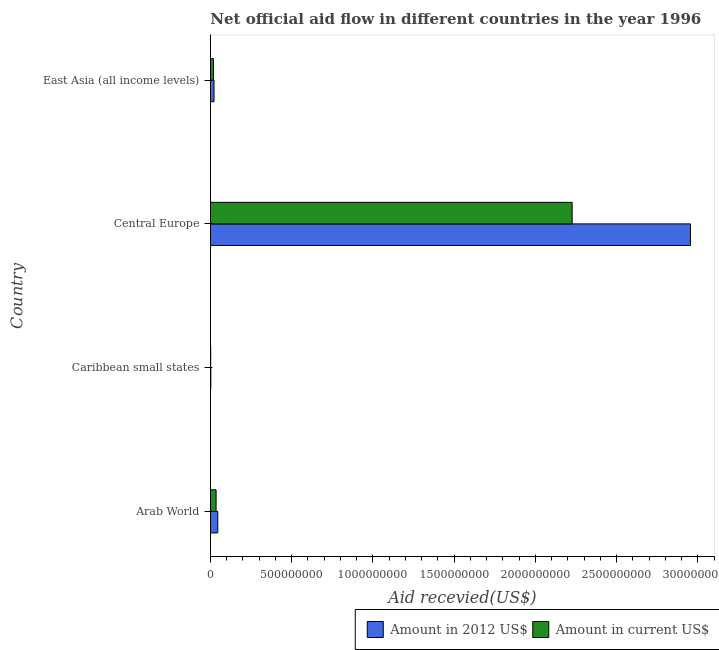How many different coloured bars are there?
Provide a succinct answer. 2. How many bars are there on the 1st tick from the top?
Keep it short and to the point. 2. What is the label of the 2nd group of bars from the top?
Your answer should be compact. Central Europe. In how many cases, is the number of bars for a given country not equal to the number of legend labels?
Your answer should be compact. 0. What is the amount of aid received(expressed in 2012 us$) in Central Europe?
Your answer should be very brief. 2.96e+09. Across all countries, what is the maximum amount of aid received(expressed in 2012 us$)?
Give a very brief answer. 2.96e+09. Across all countries, what is the minimum amount of aid received(expressed in 2012 us$)?
Your answer should be compact. 2.04e+06. In which country was the amount of aid received(expressed in us$) maximum?
Provide a succinct answer. Central Europe. In which country was the amount of aid received(expressed in us$) minimum?
Offer a very short reply. Caribbean small states. What is the total amount of aid received(expressed in 2012 us$) in the graph?
Your answer should be very brief. 3.02e+09. What is the difference between the amount of aid received(expressed in 2012 us$) in Arab World and that in Caribbean small states?
Offer a terse response. 4.31e+07. What is the difference between the amount of aid received(expressed in us$) in Central Europe and the amount of aid received(expressed in 2012 us$) in Caribbean small states?
Offer a terse response. 2.22e+09. What is the average amount of aid received(expressed in us$) per country?
Keep it short and to the point. 5.70e+08. What is the difference between the amount of aid received(expressed in us$) and amount of aid received(expressed in 2012 us$) in Caribbean small states?
Your answer should be compact. -5.90e+05. In how many countries, is the amount of aid received(expressed in us$) greater than 2300000000 US$?
Ensure brevity in your answer.  0. What is the ratio of the amount of aid received(expressed in us$) in Arab World to that in Caribbean small states?
Provide a short and direct response. 23.86. Is the difference between the amount of aid received(expressed in us$) in Caribbean small states and East Asia (all income levels) greater than the difference between the amount of aid received(expressed in 2012 us$) in Caribbean small states and East Asia (all income levels)?
Your answer should be very brief. Yes. What is the difference between the highest and the second highest amount of aid received(expressed in 2012 us$)?
Ensure brevity in your answer.  2.91e+09. What is the difference between the highest and the lowest amount of aid received(expressed in us$)?
Offer a terse response. 2.23e+09. In how many countries, is the amount of aid received(expressed in 2012 us$) greater than the average amount of aid received(expressed in 2012 us$) taken over all countries?
Provide a succinct answer. 1. Is the sum of the amount of aid received(expressed in 2012 us$) in Caribbean small states and Central Europe greater than the maximum amount of aid received(expressed in us$) across all countries?
Give a very brief answer. Yes. What does the 1st bar from the top in Arab World represents?
Provide a short and direct response. Amount in current US$. What does the 2nd bar from the bottom in Caribbean small states represents?
Offer a very short reply. Amount in current US$. How many bars are there?
Your response must be concise. 8. How many countries are there in the graph?
Your answer should be very brief. 4. What is the difference between two consecutive major ticks on the X-axis?
Your response must be concise. 5.00e+08. Does the graph contain grids?
Offer a terse response. No. How many legend labels are there?
Offer a terse response. 2. What is the title of the graph?
Give a very brief answer. Net official aid flow in different countries in the year 1996. Does "Money lenders" appear as one of the legend labels in the graph?
Provide a short and direct response. No. What is the label or title of the X-axis?
Provide a short and direct response. Aid recevied(US$). What is the Aid recevied(US$) of Amount in 2012 US$ in Arab World?
Offer a terse response. 4.51e+07. What is the Aid recevied(US$) of Amount in current US$ in Arab World?
Your answer should be compact. 3.46e+07. What is the Aid recevied(US$) in Amount in 2012 US$ in Caribbean small states?
Give a very brief answer. 2.04e+06. What is the Aid recevied(US$) in Amount in current US$ in Caribbean small states?
Your response must be concise. 1.45e+06. What is the Aid recevied(US$) in Amount in 2012 US$ in Central Europe?
Ensure brevity in your answer.  2.96e+09. What is the Aid recevied(US$) in Amount in current US$ in Central Europe?
Make the answer very short. 2.23e+09. What is the Aid recevied(US$) of Amount in 2012 US$ in East Asia (all income levels)?
Your response must be concise. 2.17e+07. What is the Aid recevied(US$) of Amount in current US$ in East Asia (all income levels)?
Make the answer very short. 1.80e+07. Across all countries, what is the maximum Aid recevied(US$) in Amount in 2012 US$?
Provide a short and direct response. 2.96e+09. Across all countries, what is the maximum Aid recevied(US$) in Amount in current US$?
Your response must be concise. 2.23e+09. Across all countries, what is the minimum Aid recevied(US$) in Amount in 2012 US$?
Offer a very short reply. 2.04e+06. Across all countries, what is the minimum Aid recevied(US$) in Amount in current US$?
Offer a terse response. 1.45e+06. What is the total Aid recevied(US$) of Amount in 2012 US$ in the graph?
Your response must be concise. 3.02e+09. What is the total Aid recevied(US$) of Amount in current US$ in the graph?
Offer a very short reply. 2.28e+09. What is the difference between the Aid recevied(US$) of Amount in 2012 US$ in Arab World and that in Caribbean small states?
Offer a terse response. 4.31e+07. What is the difference between the Aid recevied(US$) of Amount in current US$ in Arab World and that in Caribbean small states?
Give a very brief answer. 3.31e+07. What is the difference between the Aid recevied(US$) in Amount in 2012 US$ in Arab World and that in Central Europe?
Give a very brief answer. -2.91e+09. What is the difference between the Aid recevied(US$) of Amount in current US$ in Arab World and that in Central Europe?
Make the answer very short. -2.19e+09. What is the difference between the Aid recevied(US$) in Amount in 2012 US$ in Arab World and that in East Asia (all income levels)?
Your answer should be very brief. 2.34e+07. What is the difference between the Aid recevied(US$) of Amount in current US$ in Arab World and that in East Asia (all income levels)?
Give a very brief answer. 1.65e+07. What is the difference between the Aid recevied(US$) in Amount in 2012 US$ in Caribbean small states and that in Central Europe?
Give a very brief answer. -2.95e+09. What is the difference between the Aid recevied(US$) in Amount in current US$ in Caribbean small states and that in Central Europe?
Provide a short and direct response. -2.23e+09. What is the difference between the Aid recevied(US$) of Amount in 2012 US$ in Caribbean small states and that in East Asia (all income levels)?
Offer a very short reply. -1.96e+07. What is the difference between the Aid recevied(US$) of Amount in current US$ in Caribbean small states and that in East Asia (all income levels)?
Your response must be concise. -1.66e+07. What is the difference between the Aid recevied(US$) in Amount in 2012 US$ in Central Europe and that in East Asia (all income levels)?
Offer a very short reply. 2.93e+09. What is the difference between the Aid recevied(US$) in Amount in current US$ in Central Europe and that in East Asia (all income levels)?
Provide a short and direct response. 2.21e+09. What is the difference between the Aid recevied(US$) of Amount in 2012 US$ in Arab World and the Aid recevied(US$) of Amount in current US$ in Caribbean small states?
Offer a terse response. 4.37e+07. What is the difference between the Aid recevied(US$) of Amount in 2012 US$ in Arab World and the Aid recevied(US$) of Amount in current US$ in Central Europe?
Ensure brevity in your answer.  -2.18e+09. What is the difference between the Aid recevied(US$) of Amount in 2012 US$ in Arab World and the Aid recevied(US$) of Amount in current US$ in East Asia (all income levels)?
Your answer should be very brief. 2.71e+07. What is the difference between the Aid recevied(US$) of Amount in 2012 US$ in Caribbean small states and the Aid recevied(US$) of Amount in current US$ in Central Europe?
Provide a short and direct response. -2.22e+09. What is the difference between the Aid recevied(US$) in Amount in 2012 US$ in Caribbean small states and the Aid recevied(US$) in Amount in current US$ in East Asia (all income levels)?
Your answer should be compact. -1.60e+07. What is the difference between the Aid recevied(US$) in Amount in 2012 US$ in Central Europe and the Aid recevied(US$) in Amount in current US$ in East Asia (all income levels)?
Provide a short and direct response. 2.94e+09. What is the average Aid recevied(US$) in Amount in 2012 US$ per country?
Keep it short and to the point. 7.56e+08. What is the average Aid recevied(US$) of Amount in current US$ per country?
Your answer should be compact. 5.70e+08. What is the difference between the Aid recevied(US$) in Amount in 2012 US$ and Aid recevied(US$) in Amount in current US$ in Arab World?
Provide a succinct answer. 1.05e+07. What is the difference between the Aid recevied(US$) of Amount in 2012 US$ and Aid recevied(US$) of Amount in current US$ in Caribbean small states?
Your answer should be very brief. 5.90e+05. What is the difference between the Aid recevied(US$) in Amount in 2012 US$ and Aid recevied(US$) in Amount in current US$ in Central Europe?
Make the answer very short. 7.29e+08. What is the difference between the Aid recevied(US$) in Amount in 2012 US$ and Aid recevied(US$) in Amount in current US$ in East Asia (all income levels)?
Your response must be concise. 3.64e+06. What is the ratio of the Aid recevied(US$) of Amount in 2012 US$ in Arab World to that in Caribbean small states?
Keep it short and to the point. 22.12. What is the ratio of the Aid recevied(US$) in Amount in current US$ in Arab World to that in Caribbean small states?
Give a very brief answer. 23.86. What is the ratio of the Aid recevied(US$) of Amount in 2012 US$ in Arab World to that in Central Europe?
Make the answer very short. 0.02. What is the ratio of the Aid recevied(US$) in Amount in current US$ in Arab World to that in Central Europe?
Provide a short and direct response. 0.02. What is the ratio of the Aid recevied(US$) in Amount in 2012 US$ in Arab World to that in East Asia (all income levels)?
Offer a terse response. 2.08. What is the ratio of the Aid recevied(US$) of Amount in current US$ in Arab World to that in East Asia (all income levels)?
Offer a very short reply. 1.92. What is the ratio of the Aid recevied(US$) in Amount in 2012 US$ in Caribbean small states to that in Central Europe?
Provide a succinct answer. 0. What is the ratio of the Aid recevied(US$) in Amount in current US$ in Caribbean small states to that in Central Europe?
Make the answer very short. 0. What is the ratio of the Aid recevied(US$) in Amount in 2012 US$ in Caribbean small states to that in East Asia (all income levels)?
Make the answer very short. 0.09. What is the ratio of the Aid recevied(US$) in Amount in current US$ in Caribbean small states to that in East Asia (all income levels)?
Your response must be concise. 0.08. What is the ratio of the Aid recevied(US$) of Amount in 2012 US$ in Central Europe to that in East Asia (all income levels)?
Offer a terse response. 136.24. What is the ratio of the Aid recevied(US$) of Amount in current US$ in Central Europe to that in East Asia (all income levels)?
Make the answer very short. 123.35. What is the difference between the highest and the second highest Aid recevied(US$) of Amount in 2012 US$?
Provide a succinct answer. 2.91e+09. What is the difference between the highest and the second highest Aid recevied(US$) of Amount in current US$?
Your answer should be very brief. 2.19e+09. What is the difference between the highest and the lowest Aid recevied(US$) in Amount in 2012 US$?
Provide a succinct answer. 2.95e+09. What is the difference between the highest and the lowest Aid recevied(US$) in Amount in current US$?
Provide a short and direct response. 2.23e+09. 